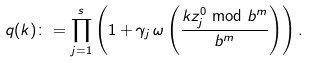<formula> <loc_0><loc_0><loc_500><loc_500>q ( k ) & \colon = \prod _ { j = 1 } ^ { s } \left ( 1 + \gamma _ { j } \, \omega \left ( \frac { k z _ { j } ^ { 0 } \bmod b ^ { m } } { b ^ { m } } \right ) \right ) .</formula> 